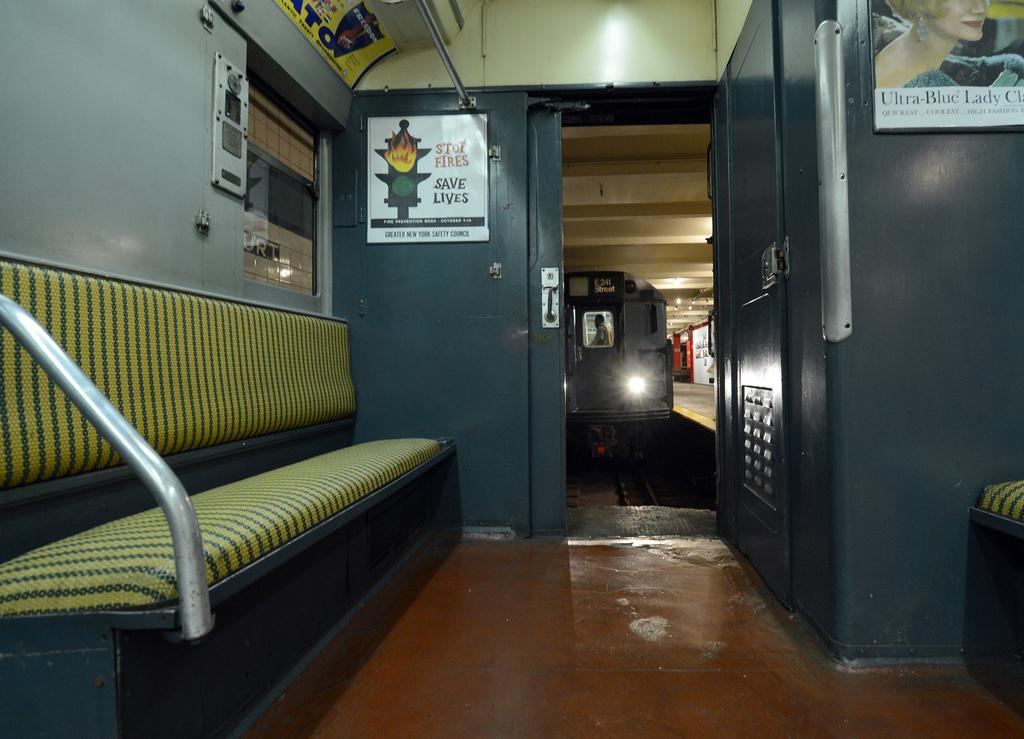<image>
Share a concise interpretation of the image provided. A sign on a train says stop fires save lives and has a picture of a flaming traffic light. 